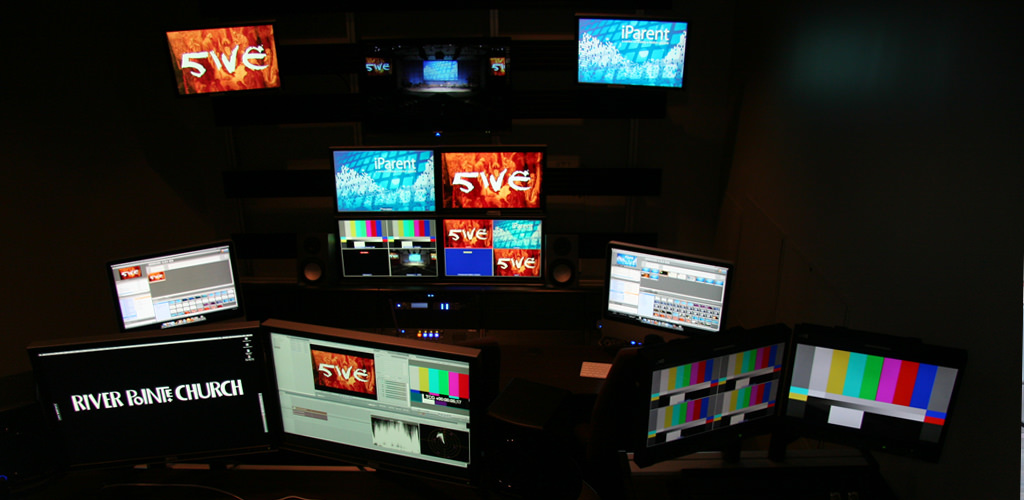Provide a one-sentence caption for the provided image. The image shows a sophisticated control room with various monitors displaying graphics, one prominently featuring 'River Pointe Church,' indicating either a broadcasting setup or a multimedia monitoring room possibly related to the church. 